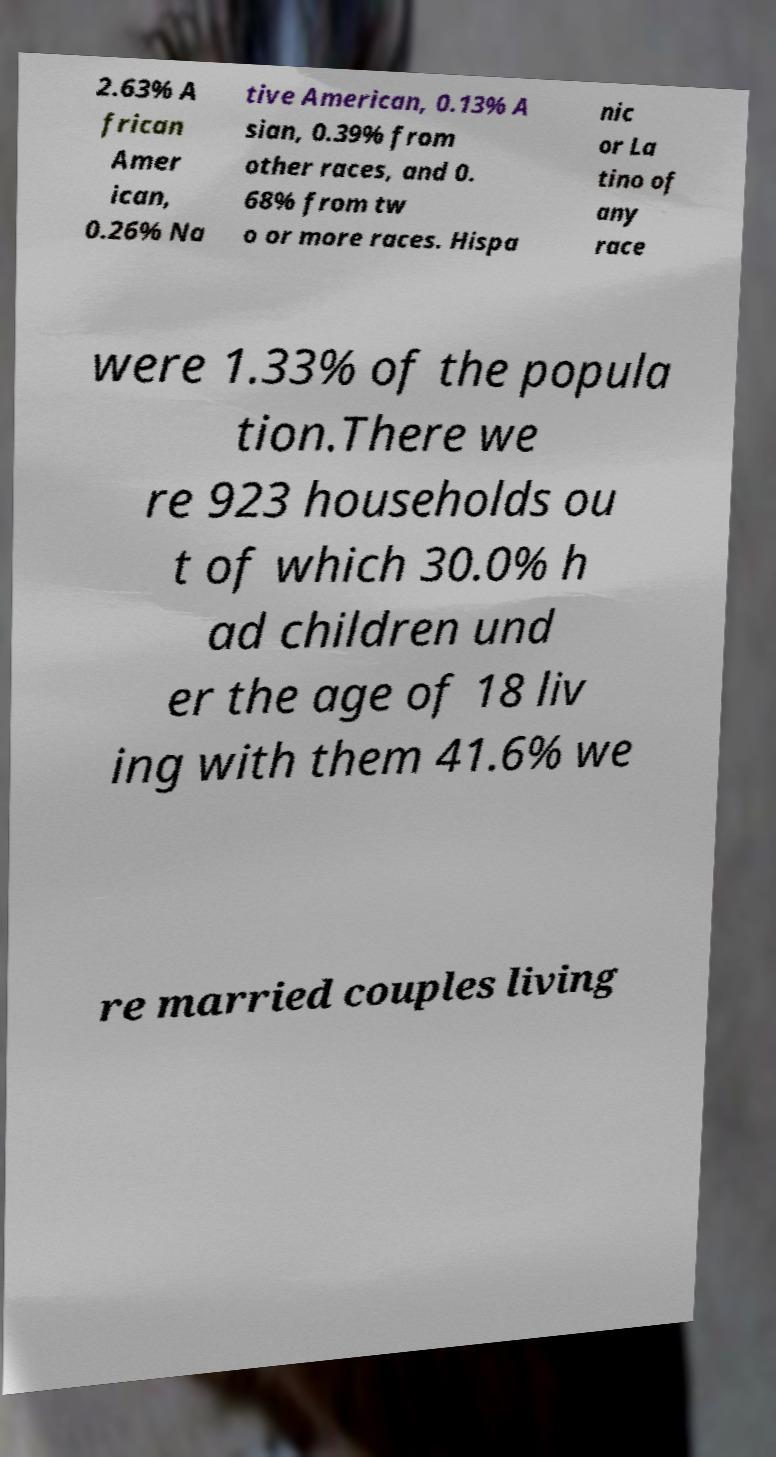Can you read and provide the text displayed in the image?This photo seems to have some interesting text. Can you extract and type it out for me? 2.63% A frican Amer ican, 0.26% Na tive American, 0.13% A sian, 0.39% from other races, and 0. 68% from tw o or more races. Hispa nic or La tino of any race were 1.33% of the popula tion.There we re 923 households ou t of which 30.0% h ad children und er the age of 18 liv ing with them 41.6% we re married couples living 